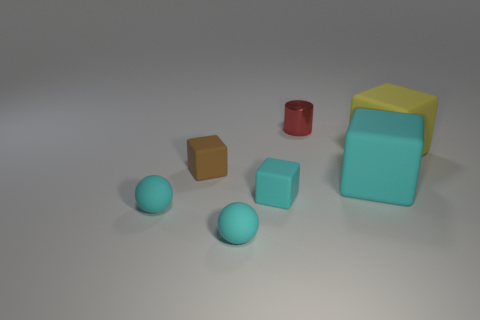Subtract all gray cylinders. How many cyan blocks are left? 2 Subtract all large cyan matte cubes. How many cubes are left? 3 Subtract all yellow blocks. How many blocks are left? 3 Add 3 small metal cylinders. How many objects exist? 10 Subtract all cubes. How many objects are left? 3 Add 3 red things. How many red things are left? 4 Add 5 big blue shiny things. How many big blue shiny things exist? 5 Subtract 0 purple spheres. How many objects are left? 7 Subtract all purple cubes. Subtract all blue balls. How many cubes are left? 4 Subtract all brown objects. Subtract all large rubber cubes. How many objects are left? 4 